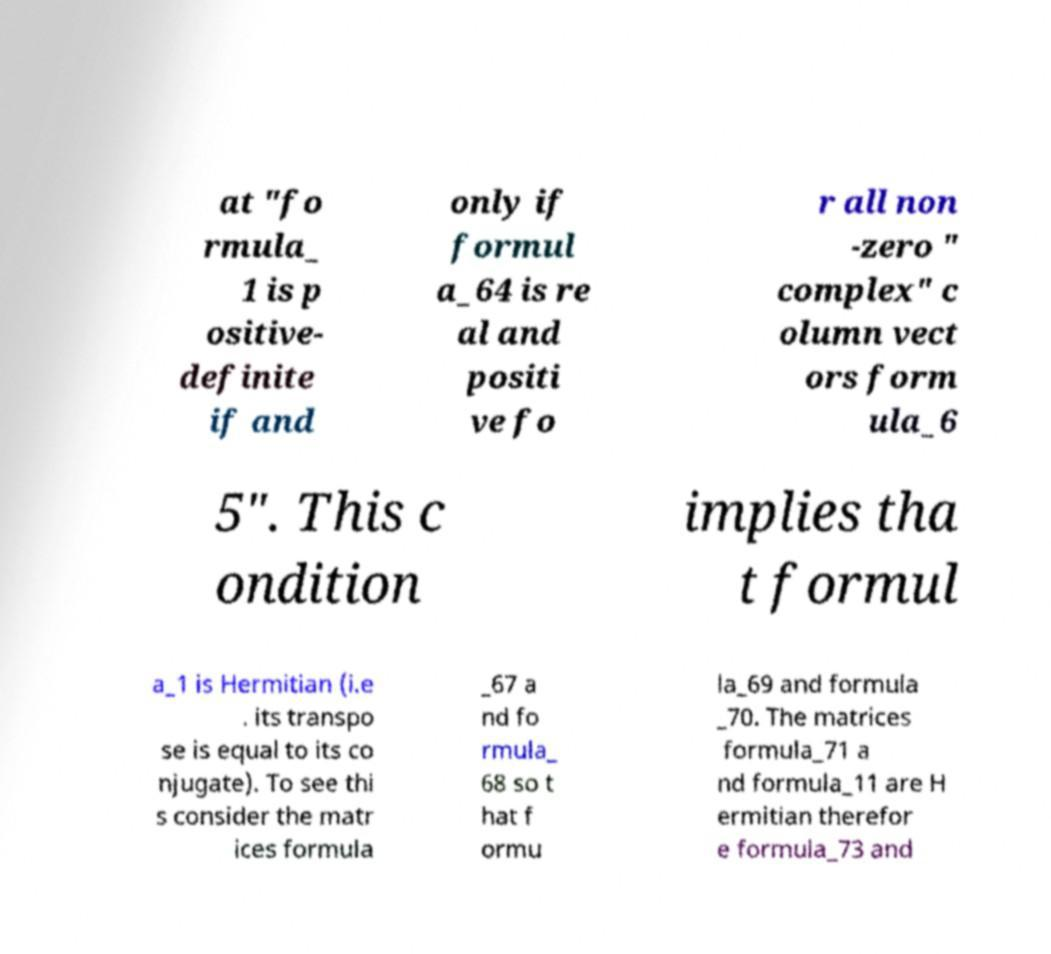Can you read and provide the text displayed in the image?This photo seems to have some interesting text. Can you extract and type it out for me? at "fo rmula_ 1 is p ositive- definite if and only if formul a_64 is re al and positi ve fo r all non -zero " complex" c olumn vect ors form ula_6 5". This c ondition implies tha t formul a_1 is Hermitian (i.e . its transpo se is equal to its co njugate). To see thi s consider the matr ices formula _67 a nd fo rmula_ 68 so t hat f ormu la_69 and formula _70. The matrices formula_71 a nd formula_11 are H ermitian therefor e formula_73 and 